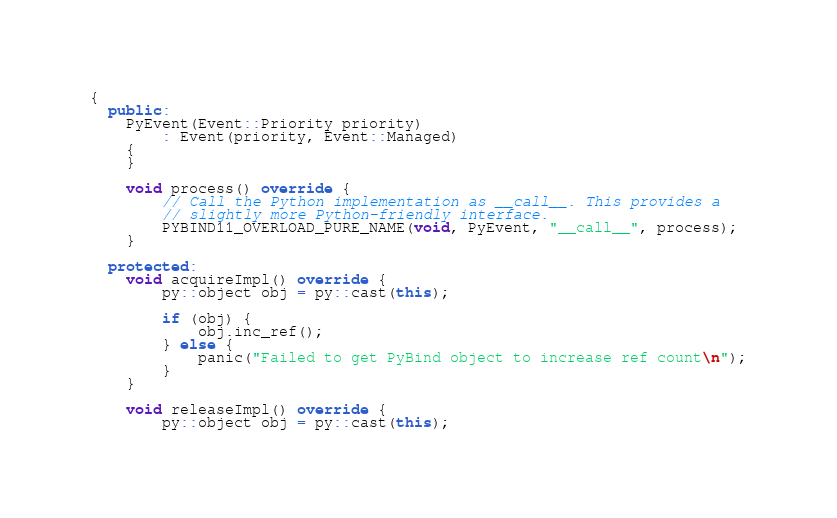<code> <loc_0><loc_0><loc_500><loc_500><_C++_>{
  public:
    PyEvent(Event::Priority priority)
        : Event(priority, Event::Managed)
    {
    }

    void process() override {
        // Call the Python implementation as __call__. This provides a
        // slightly more Python-friendly interface.
        PYBIND11_OVERLOAD_PURE_NAME(void, PyEvent, "__call__", process);
    }

  protected:
    void acquireImpl() override {
        py::object obj = py::cast(this);

        if (obj) {
            obj.inc_ref();
        } else {
            panic("Failed to get PyBind object to increase ref count\n");
        }
    }

    void releaseImpl() override {
        py::object obj = py::cast(this);
</code> 